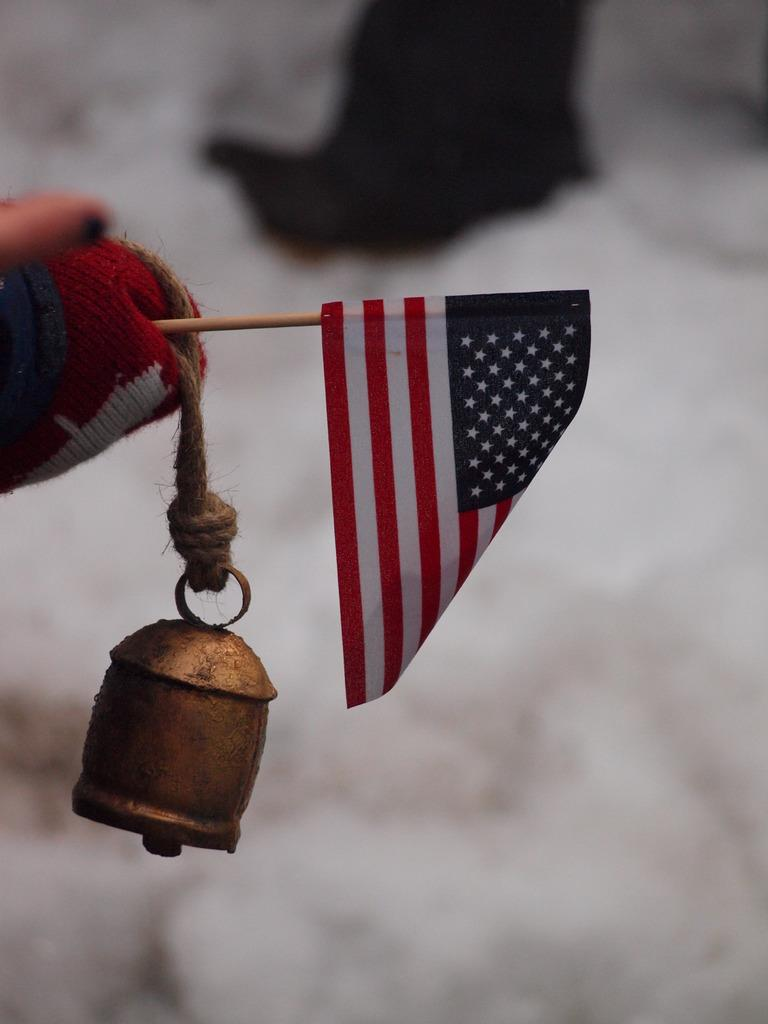What is the main subject of the image? There is a person in the image. What is the person wearing? The person is wearing a glove. What objects is the person holding? The person is holding a flag and a bell. Can you describe the background of the image? The background of the image is not clear. What type of mine is the person standing in front of in the image? There is no mine present in the image; it features a person holding a flag and a bell. How old is the boy in the image? There is no boy present in the image; it features a person holding a flag and a bell. 